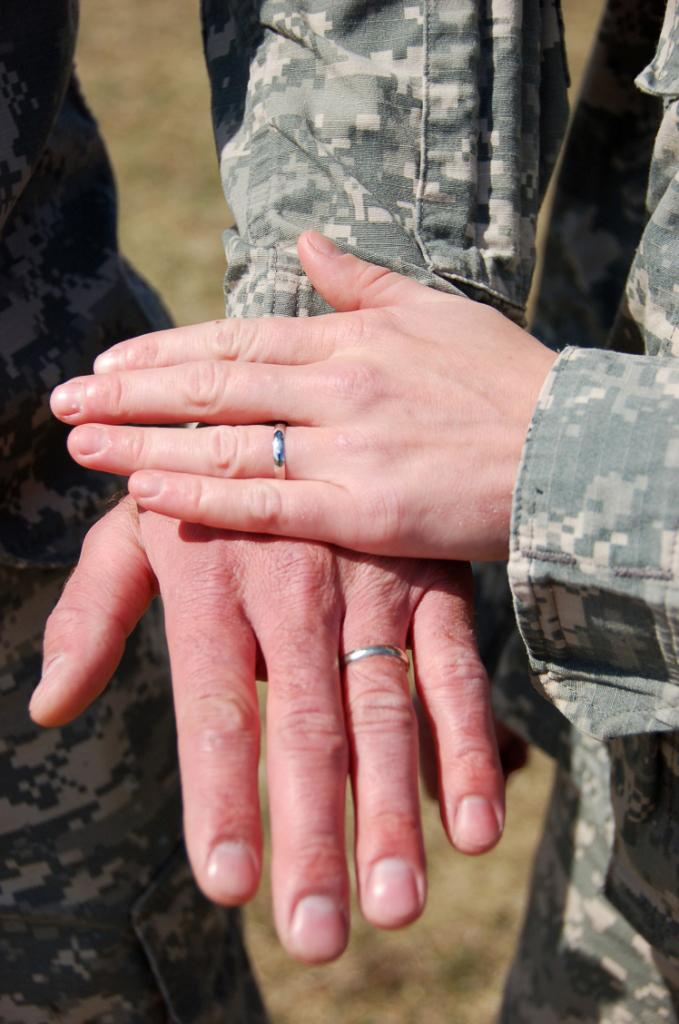What is: What is the main focus of the image? The main focus of the image is persons' hands in the center. What can be seen on the hands in the image? Hand rings are present on the hands in the image. What is visible at the bottom of the image? The ground is visible at the bottom of the image. What type of bikes are being used in the protest shown in the image? There is no protest or bikes present in the image; it only features persons' hands with hand rings. 